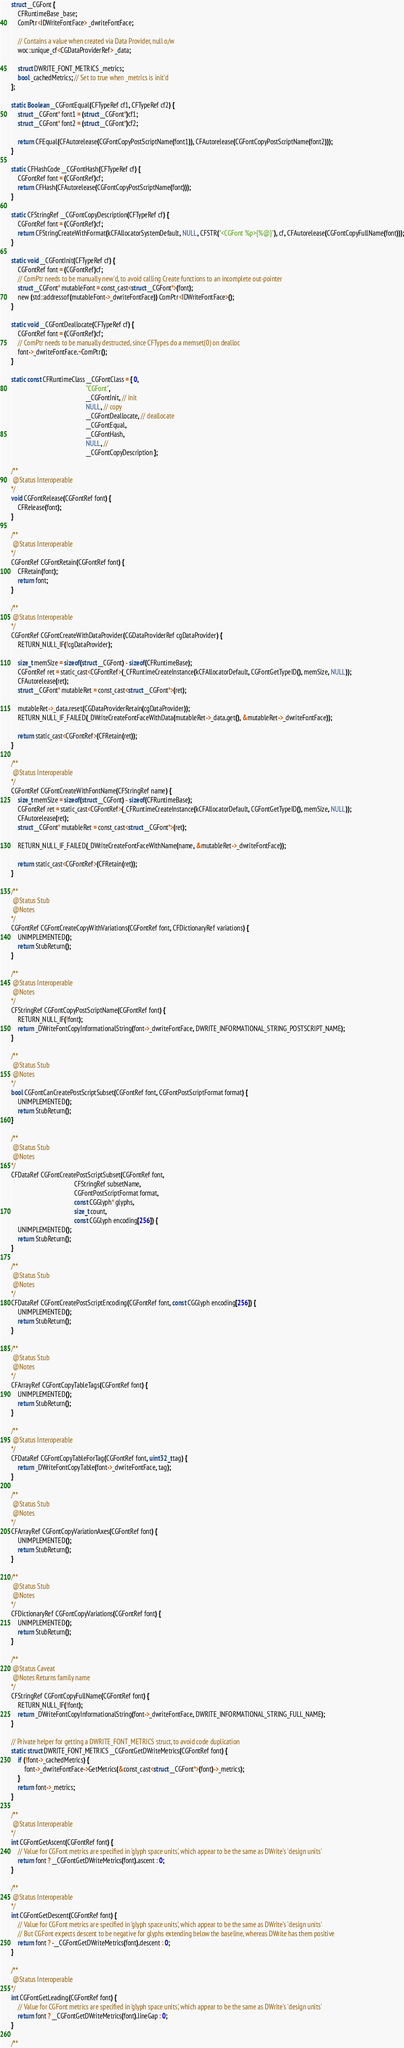<code> <loc_0><loc_0><loc_500><loc_500><_ObjectiveC_>
struct __CGFont {
    CFRuntimeBase _base;
    ComPtr<IDWriteFontFace> _dwriteFontFace;

    // Contains a value when created via Data Provider, null o/w
    woc::unique_cf<CGDataProviderRef> _data;

    struct DWRITE_FONT_METRICS _metrics;
    bool _cachedMetrics; // Set to true when _metrics is init'd
};

static Boolean __CGFontEqual(CFTypeRef cf1, CFTypeRef cf2) {
    struct __CGFont* font1 = (struct __CGFont*)cf1;
    struct __CGFont* font2 = (struct __CGFont*)cf2;

    return CFEqual(CFAutorelease(CGFontCopyPostScriptName(font1)), CFAutorelease(CGFontCopyPostScriptName(font2)));
}

static CFHashCode __CGFontHash(CFTypeRef cf) {
    CGFontRef font = (CGFontRef)cf;
    return CFHash(CFAutorelease(CGFontCopyPostScriptName(font)));
}

static CFStringRef __CGFontCopyDescription(CFTypeRef cf) {
    CGFontRef font = (CGFontRef)cf;
    return CFStringCreateWithFormat(kCFAllocatorSystemDefault, NULL, CFSTR("<CGFont %p>{%@}"), cf, CFAutorelease(CGFontCopyFullName(font)));
}

static void __CGFontInit(CFTypeRef cf) {
    CGFontRef font = (CGFontRef)cf;
    // ComPtr needs to be manually new'd, to avoid calling Create functions to an incomplete out-pointer
    struct __CGFont* mutableFont = const_cast<struct __CGFont*>(font);
    new (std::addressof(mutableFont->_dwriteFontFace)) ComPtr<IDWriteFontFace>();
}

static void __CGFontDeallocate(CFTypeRef cf) {
    CGFontRef font = (CGFontRef)cf;
    // ComPtr needs to be manually destructed, since CFTypes do a memset(0) on dealloc
    font->_dwriteFontFace.~ComPtr();
}

static const CFRuntimeClass __CGFontClass = { 0,
                                              "CGFont",
                                              __CGFontInit, // init
                                              NULL, // copy
                                              __CGFontDeallocate, // deallocate
                                              __CGFontEqual,
                                              __CGFontHash,
                                              NULL, //
                                              __CGFontCopyDescription };

/**
 @Status Interoperable
*/
void CGFontRelease(CGFontRef font) {
    CFRelease(font);
}

/**
 @Status Interoperable
*/
CGFontRef CGFontRetain(CGFontRef font) {
    CFRetain(font);
    return font;
}

/**
 @Status Interoperable
*/
CGFontRef CGFontCreateWithDataProvider(CGDataProviderRef cgDataProvider) {
    RETURN_NULL_IF(!cgDataProvider);

    size_t memSize = sizeof(struct __CGFont) - sizeof(CFRuntimeBase);
    CGFontRef ret = static_cast<CGFontRef>(_CFRuntimeCreateInstance(kCFAllocatorDefault, CGFontGetTypeID(), memSize, NULL));
    CFAutorelease(ret);
    struct __CGFont* mutableRet = const_cast<struct __CGFont*>(ret);

    mutableRet->_data.reset(CGDataProviderRetain(cgDataProvider));
    RETURN_NULL_IF_FAILED(_DWriteCreateFontFaceWithData(mutableRet->_data.get(), &mutableRet->_dwriteFontFace));

    return static_cast<CGFontRef>(CFRetain(ret));
}

/**
 @Status Interoperable
*/
CGFontRef CGFontCreateWithFontName(CFStringRef name) {
    size_t memSize = sizeof(struct __CGFont) - sizeof(CFRuntimeBase);
    CGFontRef ret = static_cast<CGFontRef>(_CFRuntimeCreateInstance(kCFAllocatorDefault, CGFontGetTypeID(), memSize, NULL));
    CFAutorelease(ret);
    struct __CGFont* mutableRet = const_cast<struct __CGFont*>(ret);

    RETURN_NULL_IF_FAILED(_DWriteCreateFontFaceWithName(name, &mutableRet->_dwriteFontFace));

    return static_cast<CGFontRef>(CFRetain(ret));
}

/**
 @Status Stub
 @Notes
*/
CGFontRef CGFontCreateCopyWithVariations(CGFontRef font, CFDictionaryRef variations) {
    UNIMPLEMENTED();
    return StubReturn();
}

/**
 @Status Interoperable
 @Notes
*/
CFStringRef CGFontCopyPostScriptName(CGFontRef font) {
    RETURN_NULL_IF(!font);
    return _DWriteFontCopyInformationalString(font->_dwriteFontFace, DWRITE_INFORMATIONAL_STRING_POSTSCRIPT_NAME);
}

/**
 @Status Stub
 @Notes
*/
bool CGFontCanCreatePostScriptSubset(CGFontRef font, CGFontPostScriptFormat format) {
    UNIMPLEMENTED();
    return StubReturn();
}

/**
 @Status Stub
 @Notes
*/
CFDataRef CGFontCreatePostScriptSubset(CGFontRef font,
                                       CFStringRef subsetName,
                                       CGFontPostScriptFormat format,
                                       const CGGlyph* glyphs,
                                       size_t count,
                                       const CGGlyph encoding[256]) {
    UNIMPLEMENTED();
    return StubReturn();
}

/**
 @Status Stub
 @Notes
*/
CFDataRef CGFontCreatePostScriptEncoding(CGFontRef font, const CGGlyph encoding[256]) {
    UNIMPLEMENTED();
    return StubReturn();
}

/**
 @Status Stub
 @Notes
*/
CFArrayRef CGFontCopyTableTags(CGFontRef font) {
    UNIMPLEMENTED();
    return StubReturn();
}

/**
 @Status Interoperable
*/
CFDataRef CGFontCopyTableForTag(CGFontRef font, uint32_t tag) {
    return _DWriteFontCopyTable(font->_dwriteFontFace, tag);
}

/**
 @Status Stub
 @Notes
*/
CFArrayRef CGFontCopyVariationAxes(CGFontRef font) {
    UNIMPLEMENTED();
    return StubReturn();
}

/**
 @Status Stub
 @Notes
*/
CFDictionaryRef CGFontCopyVariations(CGFontRef font) {
    UNIMPLEMENTED();
    return StubReturn();
}

/**
 @Status Caveat
 @Notes Returns family name
*/
CFStringRef CGFontCopyFullName(CGFontRef font) {
    RETURN_NULL_IF(!font);
    return _DWriteFontCopyInformationalString(font->_dwriteFontFace, DWRITE_INFORMATIONAL_STRING_FULL_NAME);
}

// Private helper for getting a DWRITE_FONT_METRICS struct, to avoid code duplication
static struct DWRITE_FONT_METRICS __CGFontGetDWriteMetrics(CGFontRef font) {
    if (!font->_cachedMetrics) {
        font->_dwriteFontFace->GetMetrics(&const_cast<struct __CGFont*>(font)->_metrics);
    }
    return font->_metrics;
}

/**
 @Status Interoperable
*/
int CGFontGetAscent(CGFontRef font) {
    // Value for CGFont metrics are specified in 'glyph space units', which appear to be the same as DWrite's 'design units'
    return font ? __CGFontGetDWriteMetrics(font).ascent : 0;
}

/**
 @Status Interoperable
*/
int CGFontGetDescent(CGFontRef font) {
    // Value for CGFont metrics are specified in 'glyph space units', which appear to be the same as DWrite's 'design units'
    // But CGFont expects descent to be negative for glyphs extending below the baseline, whereas DWrite has them positive
    return font ? -__CGFontGetDWriteMetrics(font).descent : 0;
}

/**
 @Status Interoperable
*/
int CGFontGetLeading(CGFontRef font) {
    // Value for CGFont metrics are specified in 'glyph space units', which appear to be the same as DWrite's 'design units'
    return font ? __CGFontGetDWriteMetrics(font).lineGap : 0;
}

/**</code> 